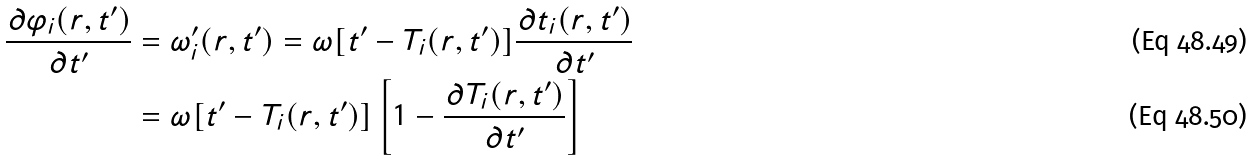Convert formula to latex. <formula><loc_0><loc_0><loc_500><loc_500>\frac { \partial \varphi _ { i } ( r , t ^ { \prime } ) } { \partial t ^ { \prime } } & = \omega _ { i } ^ { \prime } ( r , t ^ { \prime } ) = \omega [ t ^ { \prime } - T _ { i } ( r , t ^ { \prime } ) ] \frac { \partial t _ { i } ( r , t ^ { \prime } ) } { \partial t ^ { \prime } } \\ & = \omega [ t ^ { \prime } - T _ { i } ( r , t ^ { \prime } ) ] \left [ 1 - \frac { \partial T _ { i } ( r , t ^ { \prime } ) } { \partial t ^ { \prime } } \right ]</formula> 